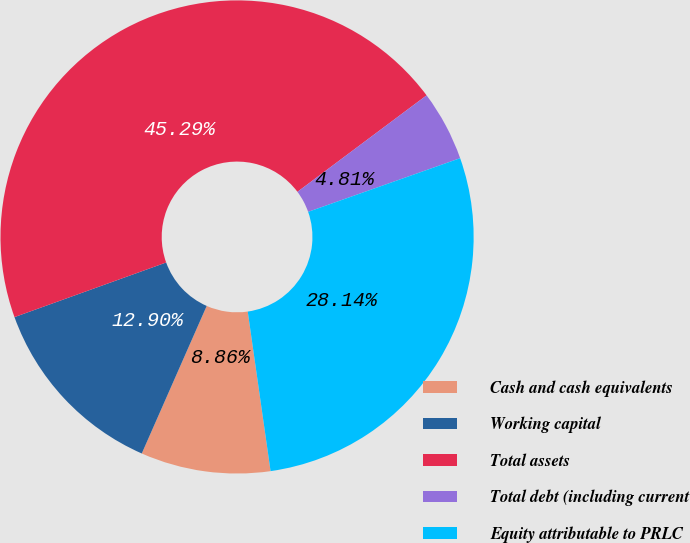Convert chart to OTSL. <chart><loc_0><loc_0><loc_500><loc_500><pie_chart><fcel>Cash and cash equivalents<fcel>Working capital<fcel>Total assets<fcel>Total debt (including current<fcel>Equity attributable to PRLC<nl><fcel>8.86%<fcel>12.9%<fcel>45.29%<fcel>4.81%<fcel>28.14%<nl></chart> 